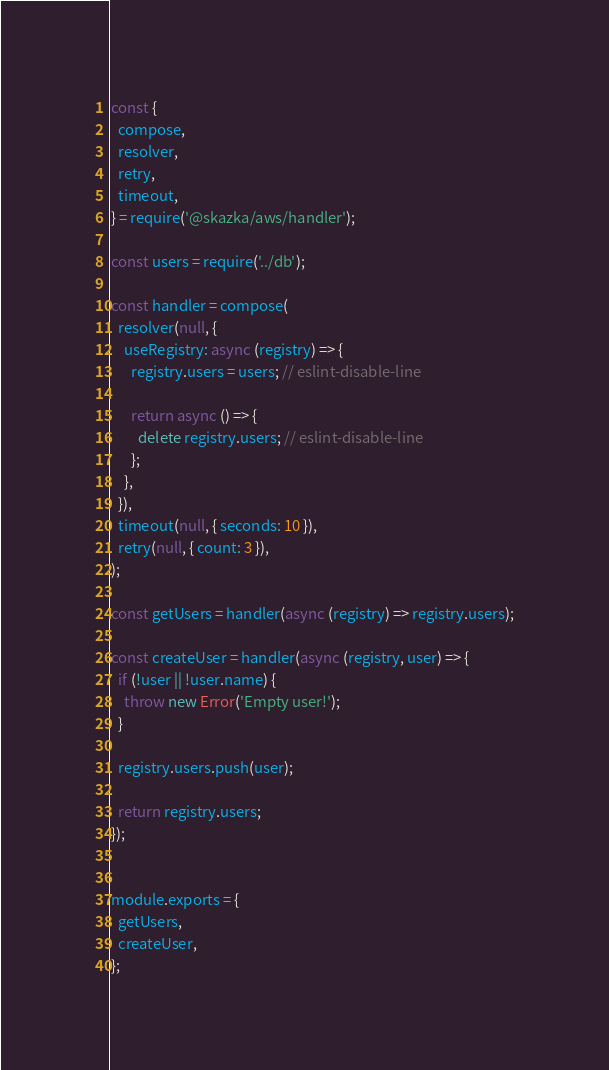Convert code to text. <code><loc_0><loc_0><loc_500><loc_500><_JavaScript_>const {
  compose,
  resolver,
  retry,
  timeout,
} = require('@skazka/aws/handler');

const users = require('../db');

const handler = compose(
  resolver(null, {
    useRegistry: async (registry) => {
      registry.users = users; // eslint-disable-line

      return async () => {
        delete registry.users; // eslint-disable-line
      };
    },
  }),
  timeout(null, { seconds: 10 }),
  retry(null, { count: 3 }),
);

const getUsers = handler(async (registry) => registry.users);

const createUser = handler(async (registry, user) => {
  if (!user || !user.name) {
    throw new Error('Empty user!');
  }

  registry.users.push(user);

  return registry.users;
});


module.exports = {
  getUsers,
  createUser,
};
</code> 